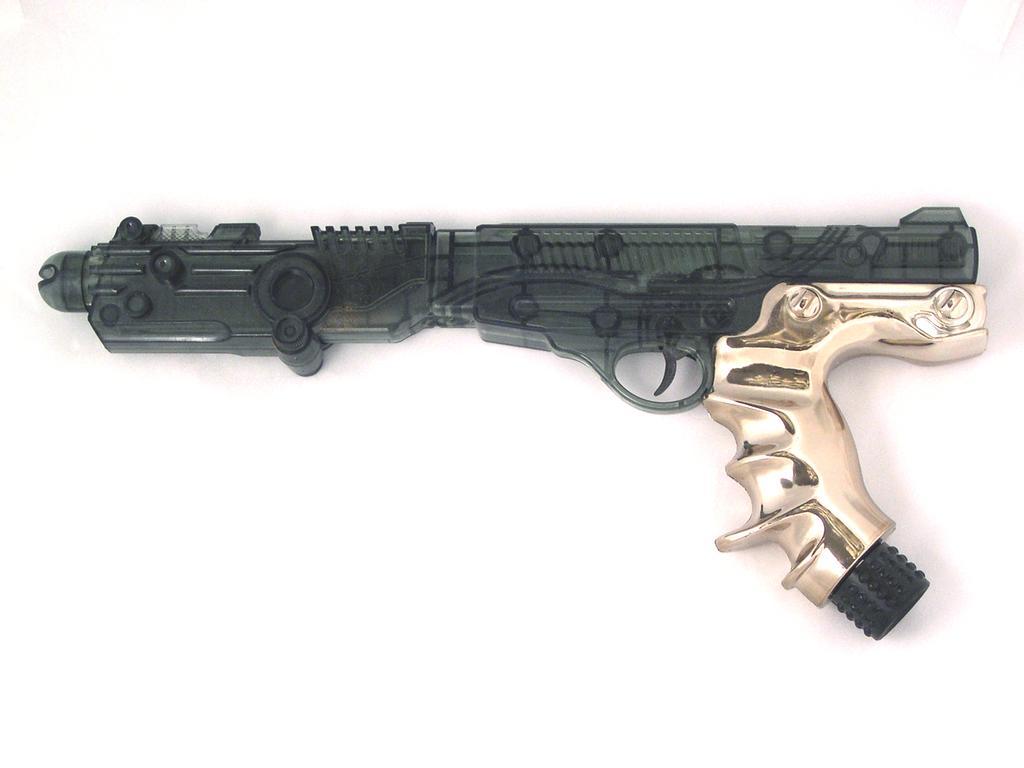Could you give a brief overview of what you see in this image? In this picture there is a gun on a white surface. 